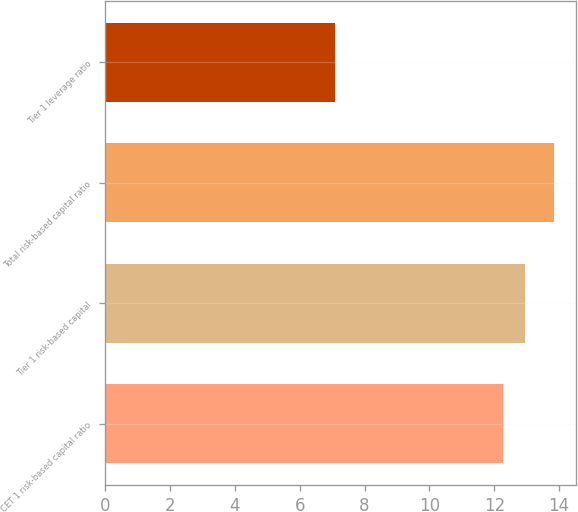<chart> <loc_0><loc_0><loc_500><loc_500><bar_chart><fcel>CET 1 risk-based capital ratio<fcel>Tier 1 risk-based capital<fcel>Total risk-based capital ratio<fcel>Tier 1 leverage ratio<nl><fcel>12.28<fcel>12.96<fcel>13.84<fcel>7.09<nl></chart> 